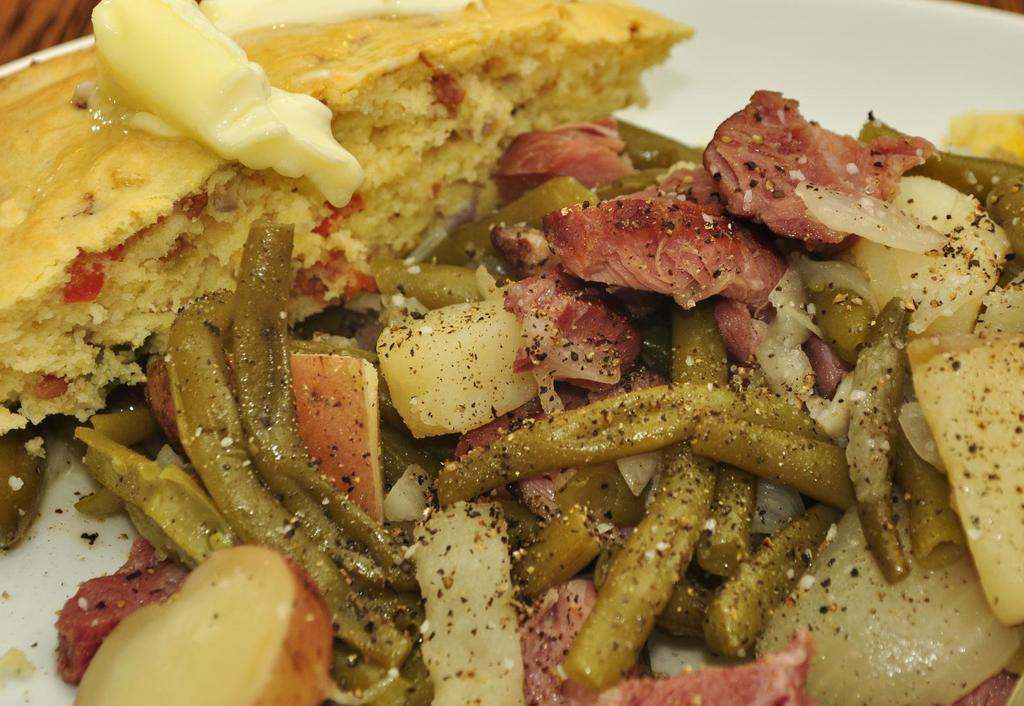What is on the serving plate in the image? The serving plate contains pie. What is on top of the pie? The pie has butter on top. What other types of food are visible in the image? There is sauteed meat and vegetables in the image. What is the limit of the writer's imagination in the image? There is no writer or limit of imagination present in the image; it features a serving plate with pie, butter, sauteed meat, and vegetables. 